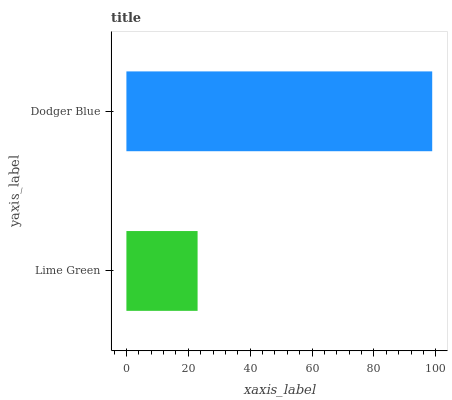Is Lime Green the minimum?
Answer yes or no. Yes. Is Dodger Blue the maximum?
Answer yes or no. Yes. Is Dodger Blue the minimum?
Answer yes or no. No. Is Dodger Blue greater than Lime Green?
Answer yes or no. Yes. Is Lime Green less than Dodger Blue?
Answer yes or no. Yes. Is Lime Green greater than Dodger Blue?
Answer yes or no. No. Is Dodger Blue less than Lime Green?
Answer yes or no. No. Is Dodger Blue the high median?
Answer yes or no. Yes. Is Lime Green the low median?
Answer yes or no. Yes. Is Lime Green the high median?
Answer yes or no. No. Is Dodger Blue the low median?
Answer yes or no. No. 